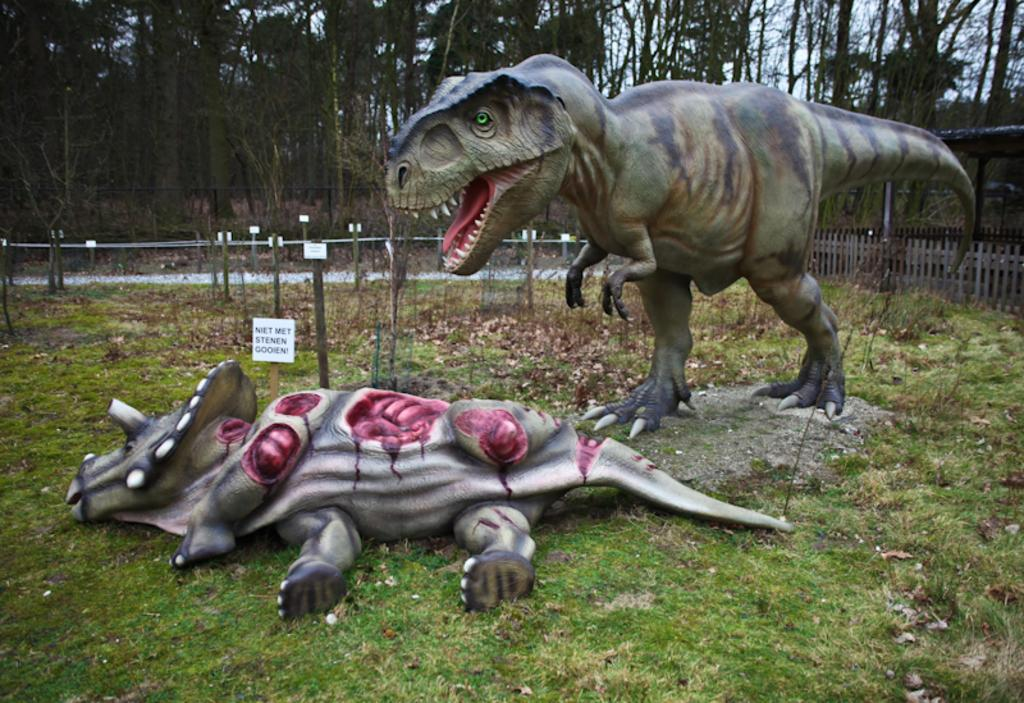What type of toys are present in the image? There are 2 dinosaur dolls in green color in the image. What is located on the right side of the image? There is an iron fence on the right side of the image. What type of clothing can be seen in the image? There is a shirt in the image. What can be seen in the background of the image? There are trees visible at the back side of the image. What time is it in the image? The image does not provide any information about the time. Are there any police officers visible in the image? There are no police officers present in the image. 